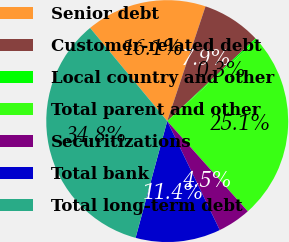Convert chart. <chart><loc_0><loc_0><loc_500><loc_500><pie_chart><fcel>Senior debt<fcel>Customer-related debt<fcel>Local country and other<fcel>Total parent and other<fcel>Securitizations<fcel>Total bank<fcel>Total long-term debt<nl><fcel>16.13%<fcel>7.9%<fcel>0.26%<fcel>25.11%<fcel>4.45%<fcel>11.36%<fcel>34.78%<nl></chart> 